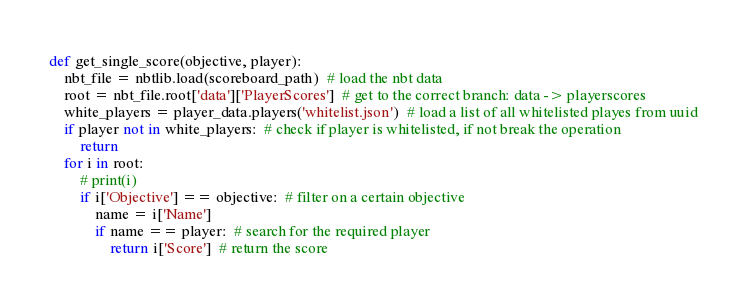Convert code to text. <code><loc_0><loc_0><loc_500><loc_500><_Python_>

def get_single_score(objective, player):
    nbt_file = nbtlib.load(scoreboard_path)  # load the nbt data
    root = nbt_file.root['data']['PlayerScores']  # get to the correct branch: data -> playerscores
    white_players = player_data.players('whitelist.json')  # load a list of all whitelisted playes from uuid
    if player not in white_players:  # check if player is whitelisted, if not break the operation
        return
    for i in root:
        # print(i)
        if i['Objective'] == objective:  # filter on a certain objective
            name = i['Name']
            if name == player:  # search for the required player
                return i['Score']  # return the score
</code> 